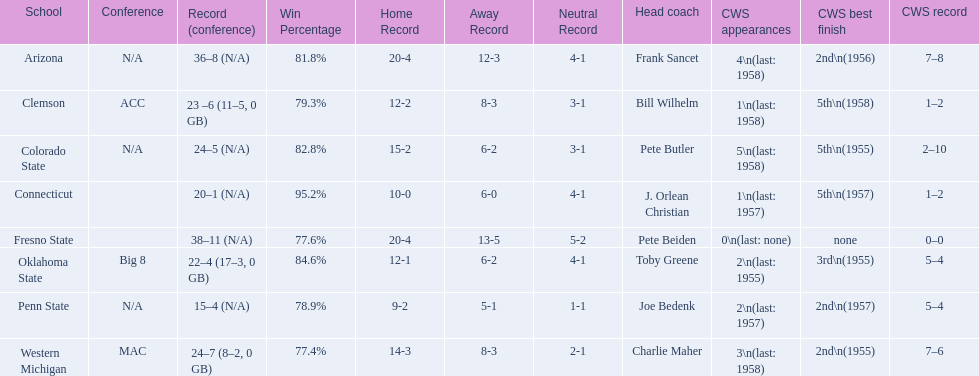What are all of the schools? Arizona, Clemson, Colorado State, Connecticut, Fresno State, Oklahoma State, Penn State, Western Michigan. Which team had fewer than 20 wins? Penn State. 